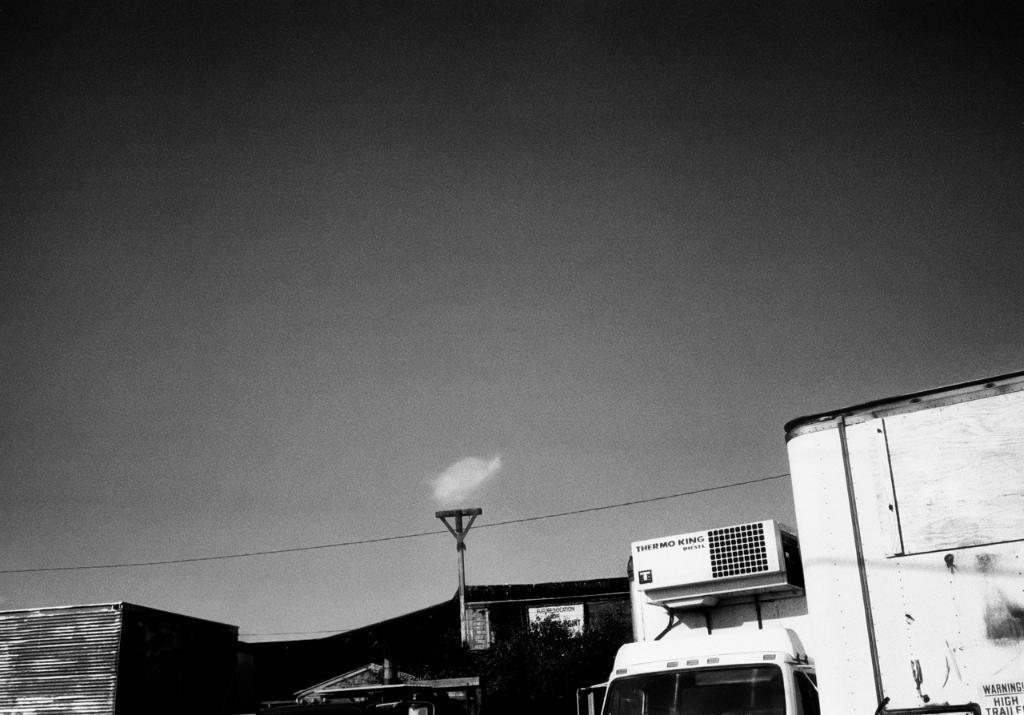Can you describe this image briefly? In this picture there is a dock on the right side of the image and there are warehouses at the bottom side of the image and there is a vehicle, poster, and a pole at the bottom side of the image, there is sky at the top side of the image. 